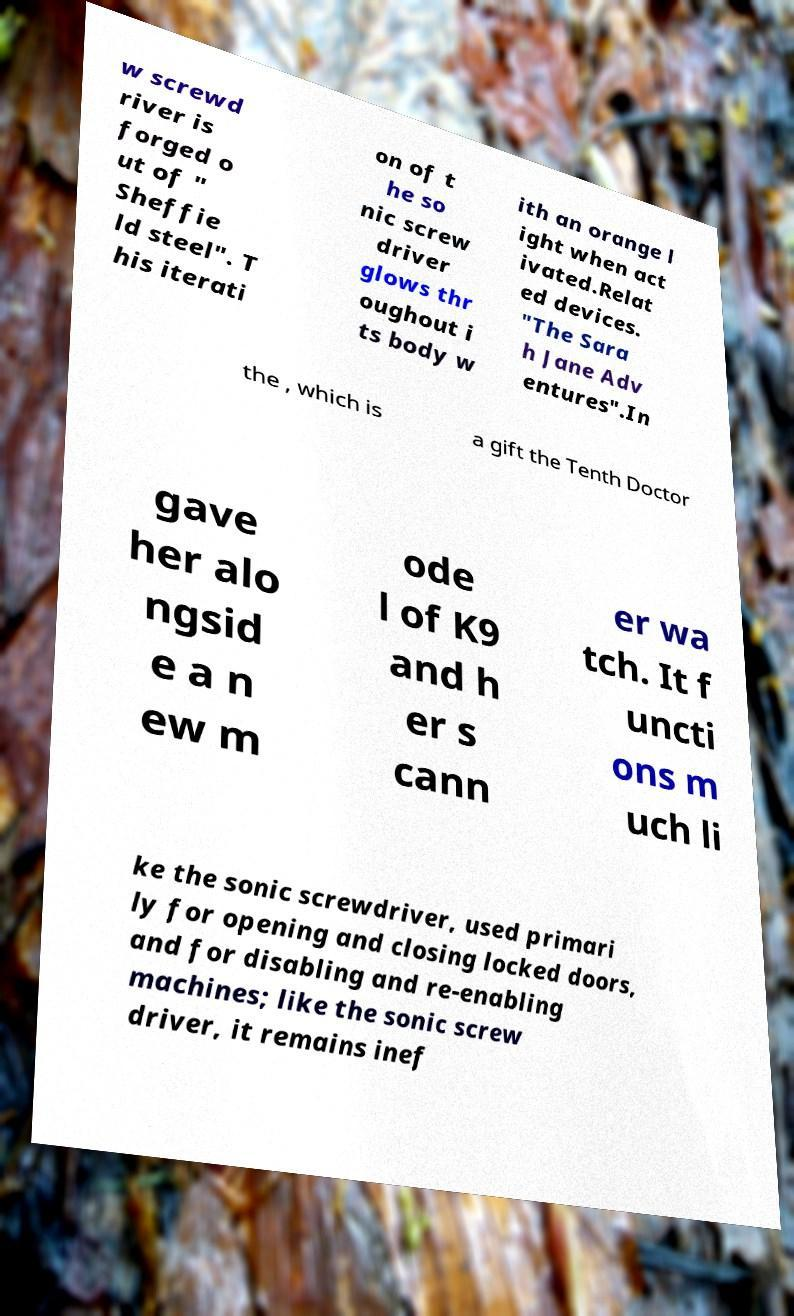There's text embedded in this image that I need extracted. Can you transcribe it verbatim? w screwd river is forged o ut of " Sheffie ld steel". T his iterati on of t he so nic screw driver glows thr oughout i ts body w ith an orange l ight when act ivated.Relat ed devices. "The Sara h Jane Adv entures".In the , which is a gift the Tenth Doctor gave her alo ngsid e a n ew m ode l of K9 and h er s cann er wa tch. It f uncti ons m uch li ke the sonic screwdriver, used primari ly for opening and closing locked doors, and for disabling and re-enabling machines; like the sonic screw driver, it remains inef 